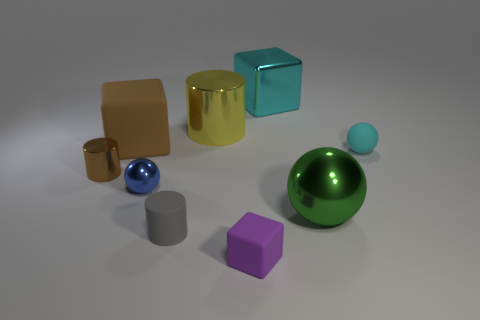Subtract all red spheres. Subtract all purple cubes. How many spheres are left? 3 Add 1 tiny rubber cylinders. How many objects exist? 10 Subtract all balls. How many objects are left? 6 Subtract 0 red blocks. How many objects are left? 9 Subtract all cylinders. Subtract all rubber blocks. How many objects are left? 4 Add 4 cyan blocks. How many cyan blocks are left? 5 Add 2 green metal balls. How many green metal balls exist? 3 